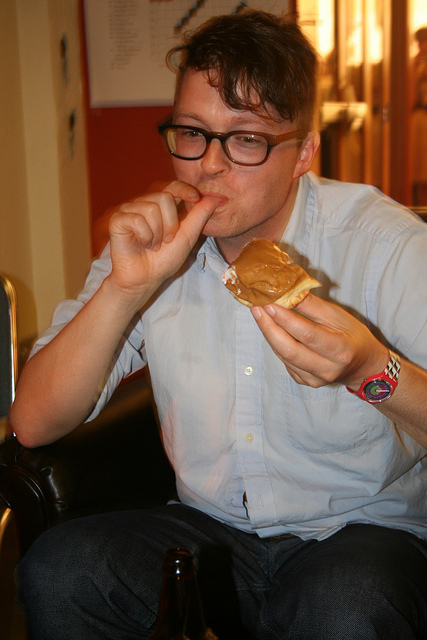<image>What sort of condiments does the man like? I am not sure what sort of condiments the man likes. It can be cream, ketchup, peanut butter, mayonnaise, tartar sauce or whipped cream. What color is the man's hat? There is no hat on the man's head. What kind of vegetable is on the sandwich? I don't know the exact answer. It could be either a tomato or lettuce present on the sandwich. What color is the man's hat? It is unknown what color the man's hat is. There is no hat visible in the image. What kind of vegetable is on the sandwich? I don't know what kind of vegetable is on the sandwich. It can be tomato or lettuce. What sort of condiments does the man like? I don't know what sort of condiments the man likes. It could be none, cream, ketchup, peanut butter, mayonnaise, tartar sauce, or whipped cream. 